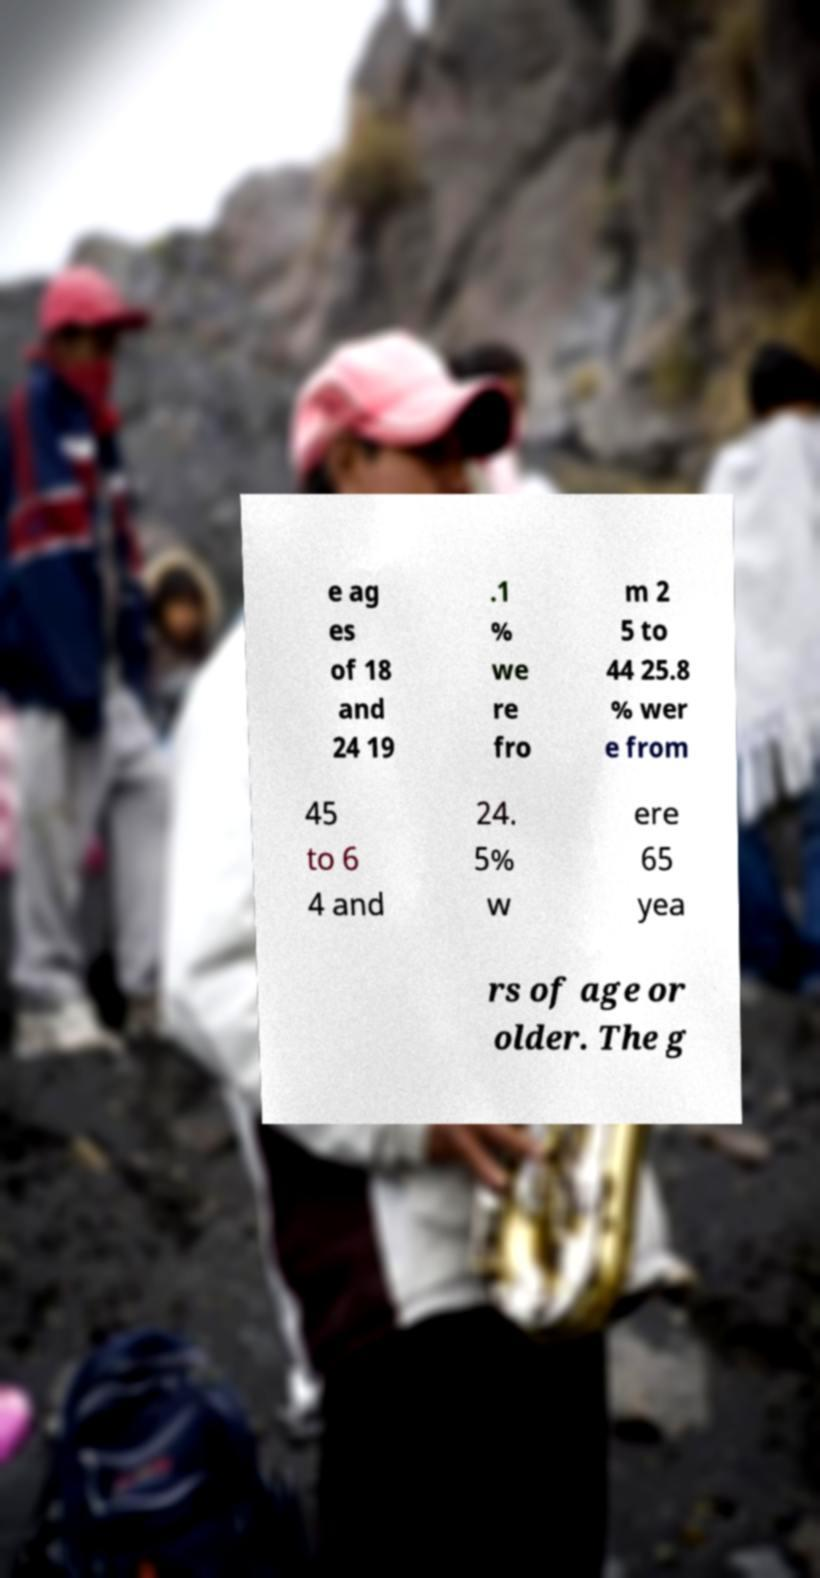For documentation purposes, I need the text within this image transcribed. Could you provide that? e ag es of 18 and 24 19 .1 % we re fro m 2 5 to 44 25.8 % wer e from 45 to 6 4 and 24. 5% w ere 65 yea rs of age or older. The g 